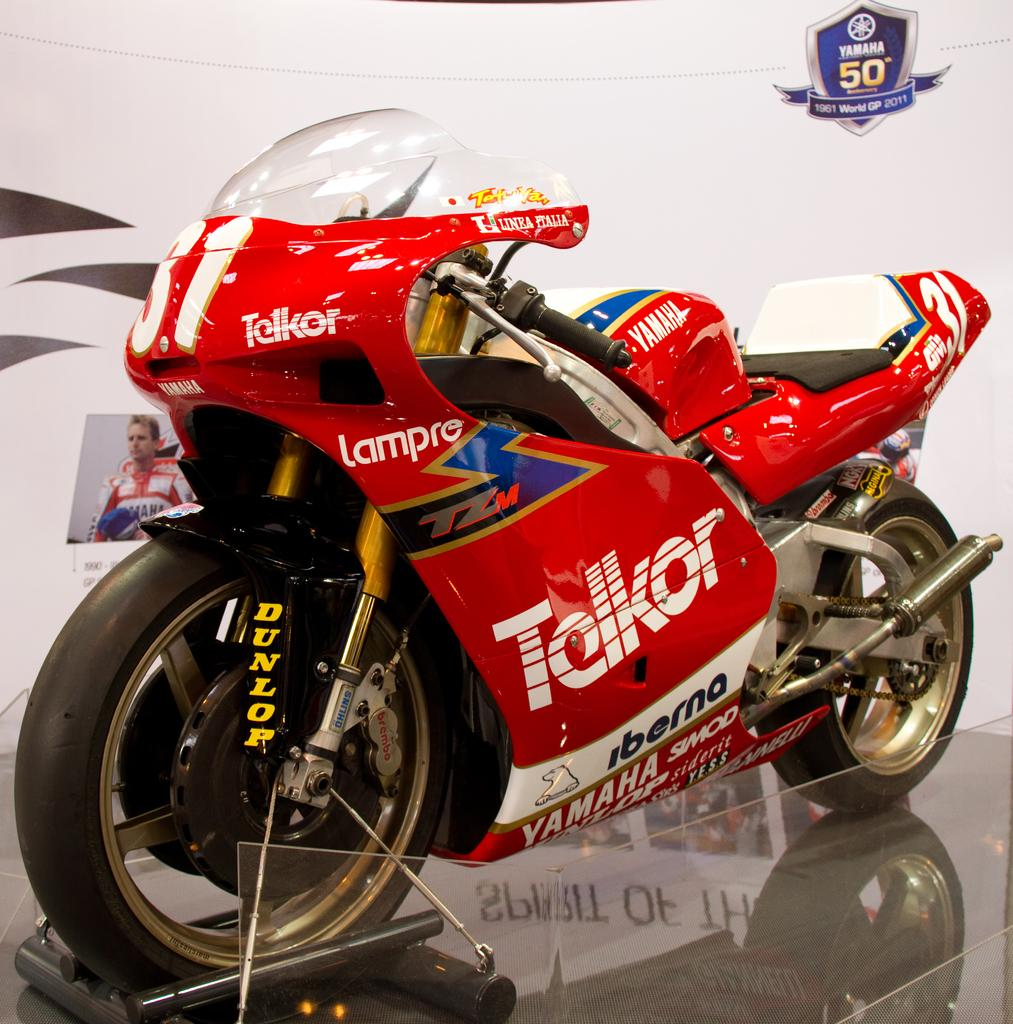What is the main subject of the image? The main subject of the image is a sports bike. Where is the sports bike located in the image? The sports bike is in the center of the image. What can be seen in the background of the image? There is a flex in the background area of the image. How many times has the cork been used in the image? There is no cork present in the image. What type of bite can be seen on the sports bike in the image? There is no bite visible on the sports bike in the image. 